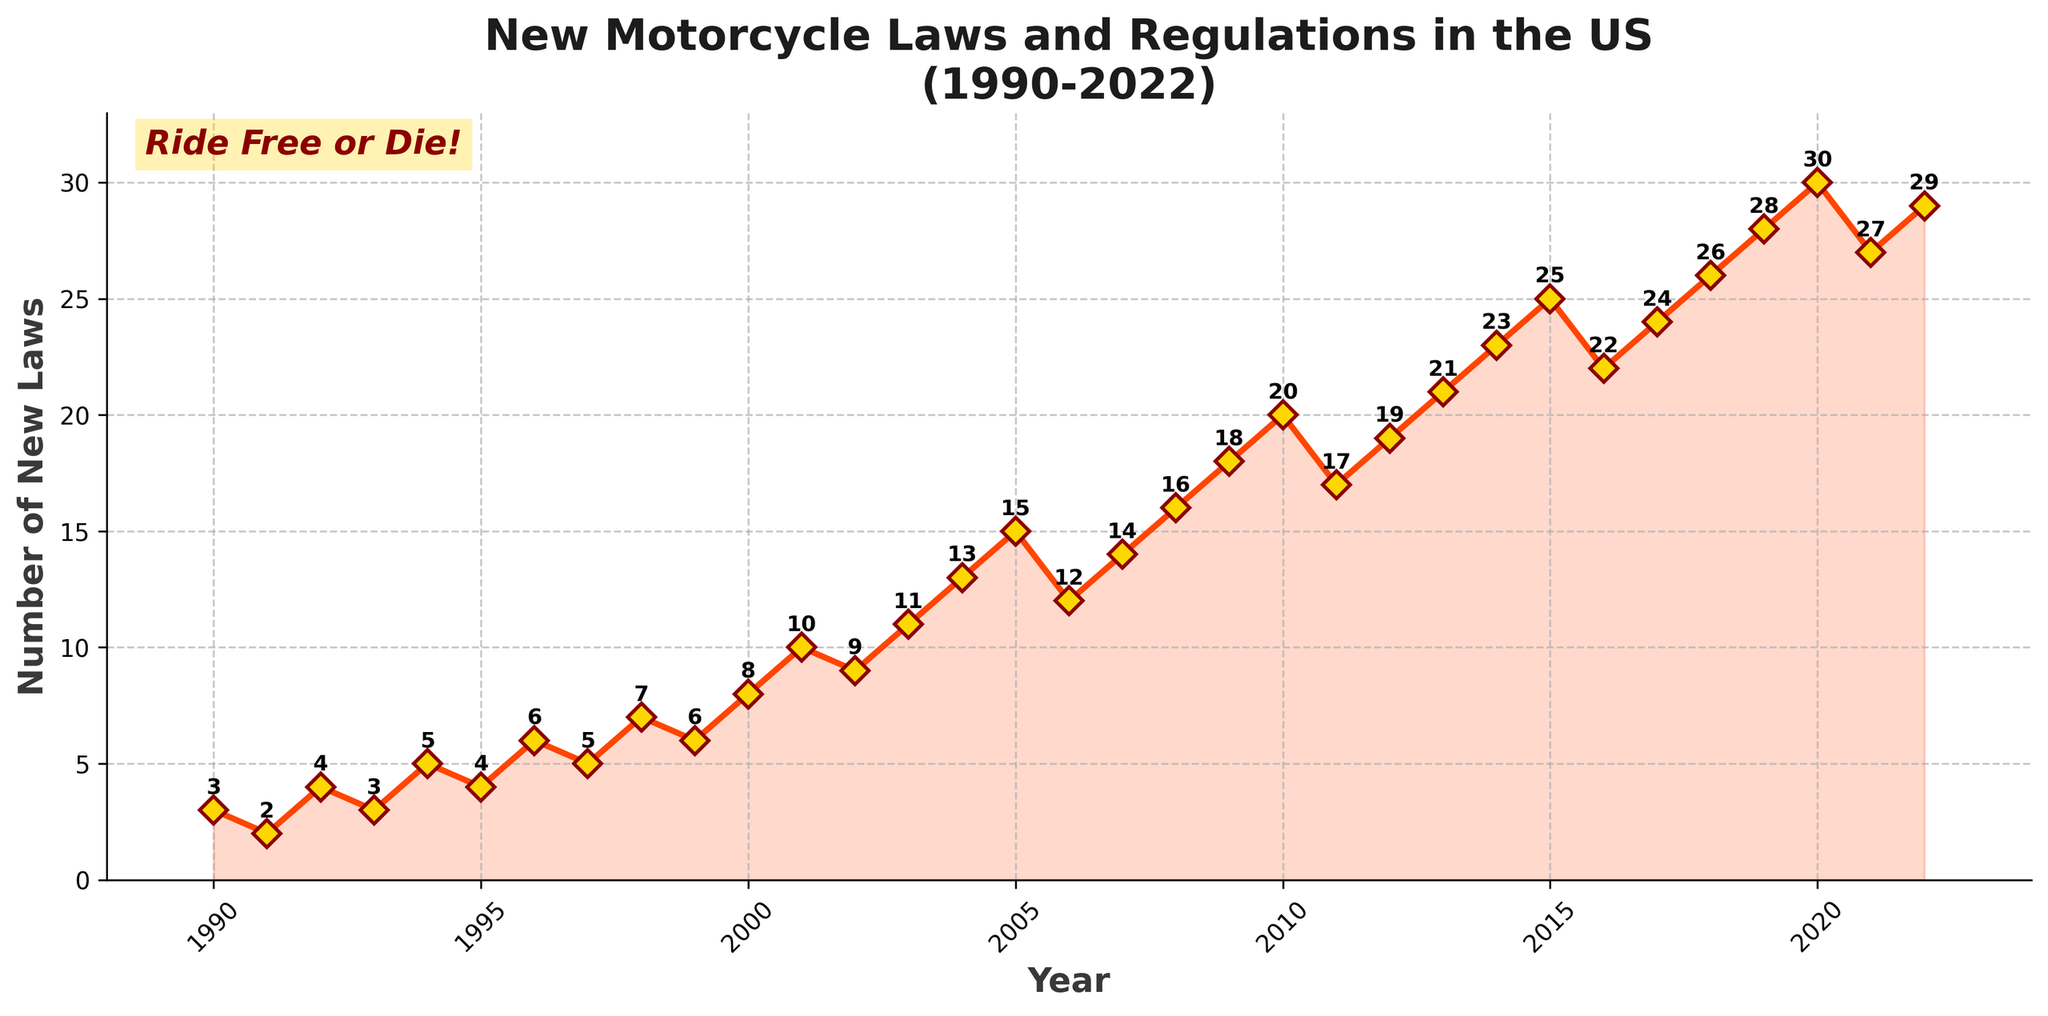What is the peak number of new motorcycle laws and regulations enacted in a single year? The peak value can be identified as the highest point on the line chart. The data label at the top of the peak will provide the exact number. The highest number is 30 enacted laws, which occurred in 2020.
Answer: 30 How many years saw an increase in the number of new motorcycle laws compared to the previous year? Observing the figure, count the number of years where the curve moves upwards between consecutive points. Out of the total time span, there are 25 increases.
Answer: 25 In which year did the number of new motorcycle laws and regulations first exceed 15 in a single year? Identify the first point on the chart above the line where y=15. From the chart, this occurs in 2005.
Answer: 2005 By how much did the number of new motorcycle laws and regulations increase from 2010 to 2020? Locate the values for 2010 and 2020 on the y-axis, then subtract the 2010 value from the 2020 value: 30 - 20 = 10.
Answer: 10 On average, how many new motorcycle laws and regulations were enacted each year from 1990 to 2000? Sum the values from 1990 to 2000 and divide by the number of years: (3 + 2 + 4 + 3 + 5 + 4 + 6 + 5 + 7 + 6 + 8) / 11 = 53 / 11 ≈ 4.82.
Answer: 4.82 Which years saw an increase of more than 5 new motorcycle laws and regulations compared to the previous year? Identify the years where the difference between consecutive points is greater than 5. This occurs between 2004 and 2005 (13 to 15).
Answer: 2005 Compare the number of new motorcycle laws enacted in 1990 and 2022. Which year had more, and by how much? Refer to the chart values for 1990 and 2022. Compare: 29 (2022) - 3 (1990). 2022 had 26 more laws enacted than 1990.
Answer: 2022 by 26 What is the average rate of increase per year in the number of new motorcycle laws from 2000 to 2022? Calculate the slope of the line segment from 2000 to 2022. The difference in values is 29 - 8, and the time span is 22 years: (29 - 8) / 22 ≈ 0.95 laws per year.
Answer: 0.95 Between which consecutive years was the largest single increase in new motorcycle laws and regulations observed? Identify the pair of consecutive years with the largest vertical gap. The largest increase occurs between 2019 and 2020 (28 to 30).
Answer: 2019-2020 